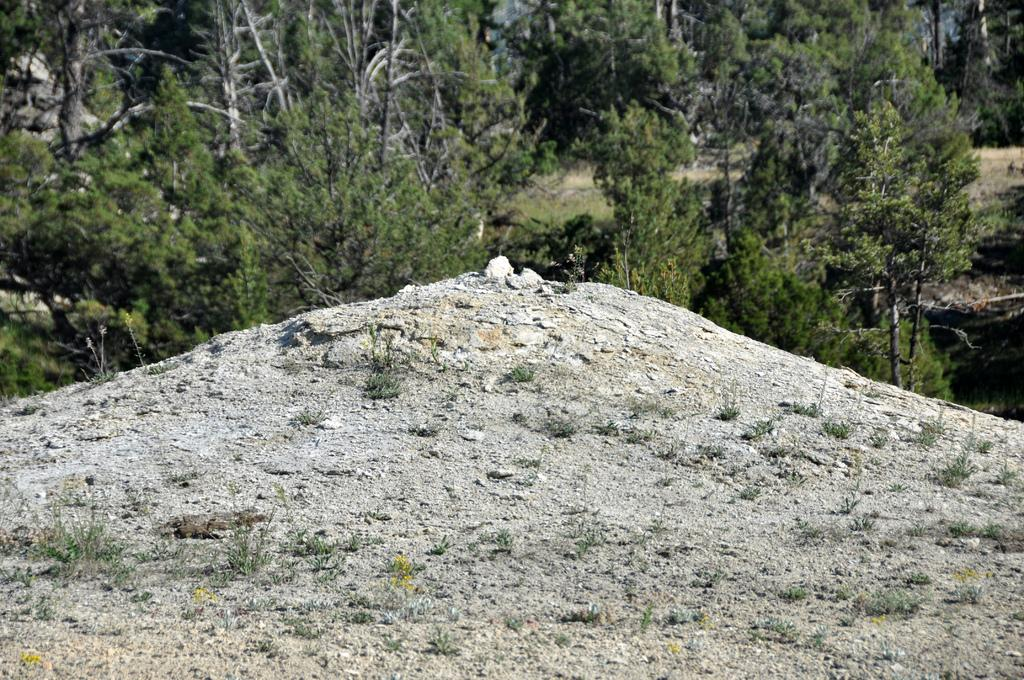What type of ground is visible in the image? The ground in the image is sandy. What can be seen in the background of the image? There are trees in the background of the image. What type of teaching method is being used in the image? There is no teaching or any indication of a teaching method present in the image. 